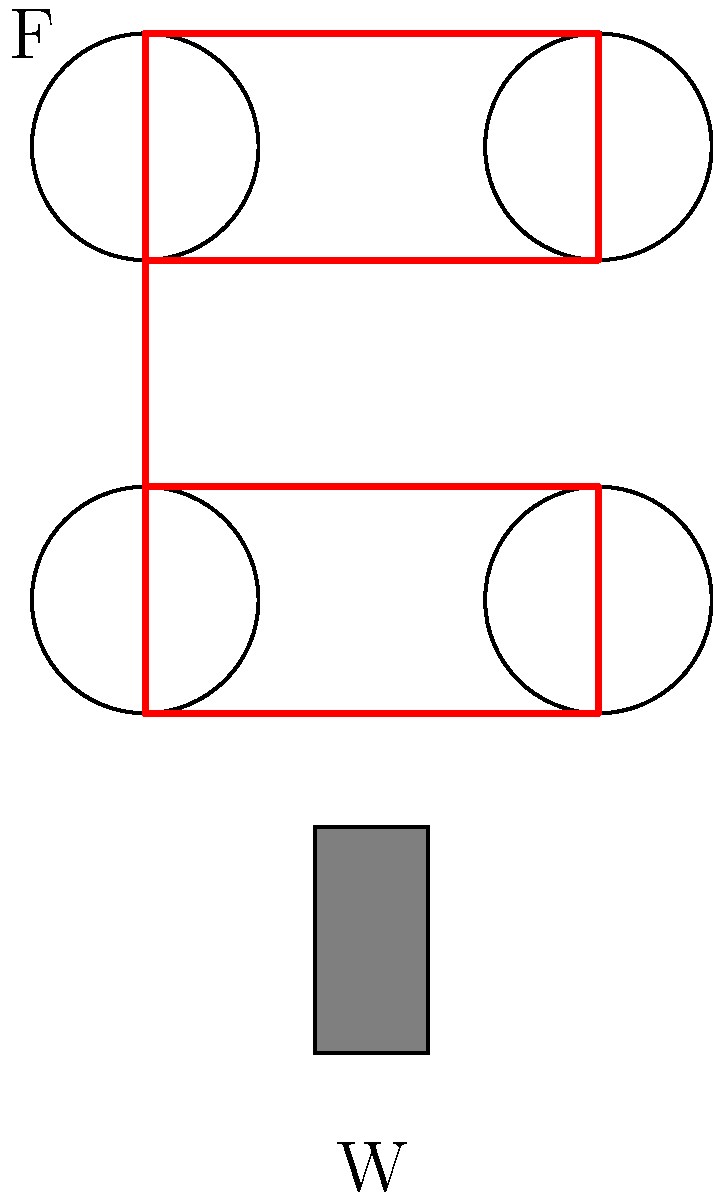As a director capturing the intricate details of a complex pulley system, you need to determine its mechanical advantage. The system consists of four pulleys arranged as shown in the diagram, with the load (W) suspended at the bottom. Calculate the mechanical advantage of this pulley system, assuming ideal conditions with no friction or rope mass. To calculate the mechanical advantage of this pulley system, we'll follow these steps:

1) First, let's understand what mechanical advantage (MA) means:
   MA = Force Output / Force Input = W / F

2) In an ideal pulley system, the tension in the rope is equal throughout.

3) Let's count the number of rope segments supporting the weight:
   There are 4 segments of rope between the pulleys supporting the weight.

4) In an ideal pulley system, each of these segments carries an equal share of the weight.
   So, if we denote the input force as F, we have:
   $$4F = W$$

5) Rearranging this equation:
   $$W = 4F$$

6) Now, we can calculate the mechanical advantage:
   $$MA = W / F = 4F / F = 4$$

Therefore, the mechanical advantage of this pulley system is 4, meaning the system multiplies the input force by a factor of 4.
Answer: 4 